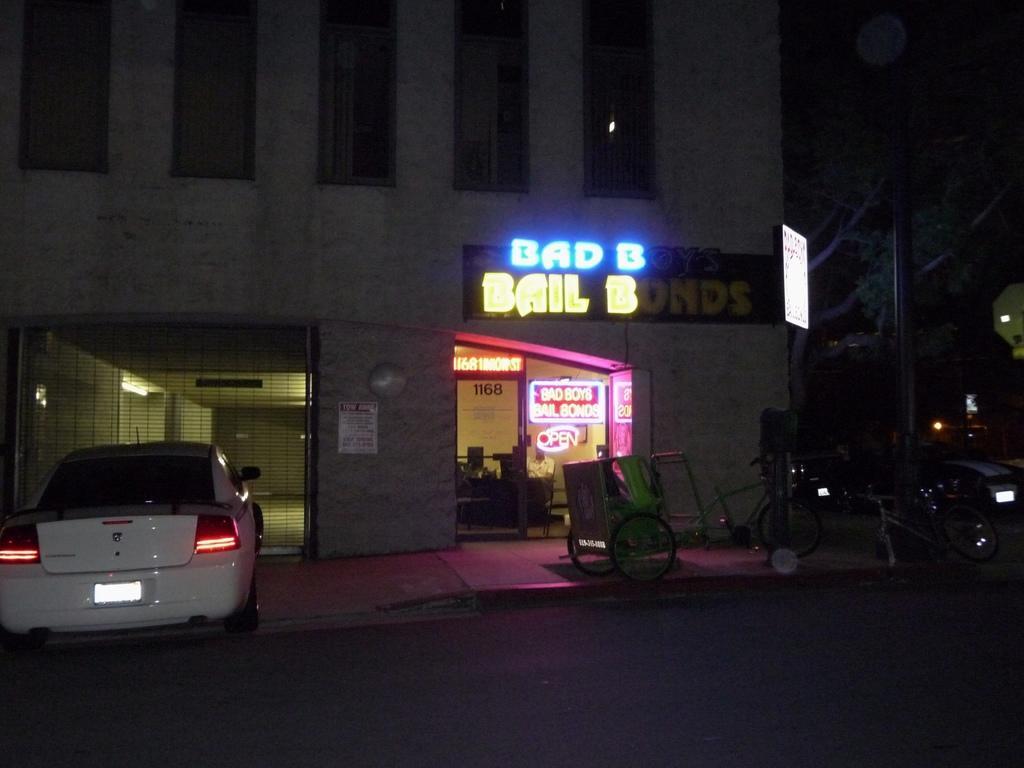In one or two sentences, can you explain what this image depicts? In the image we can see there are vehicles and a bicycle. We can even see the building and the mesh. There is even a person sitting and wearing clothes. Here we can see LED text and LED board. Here we can see the road, footpath and dark sky. 